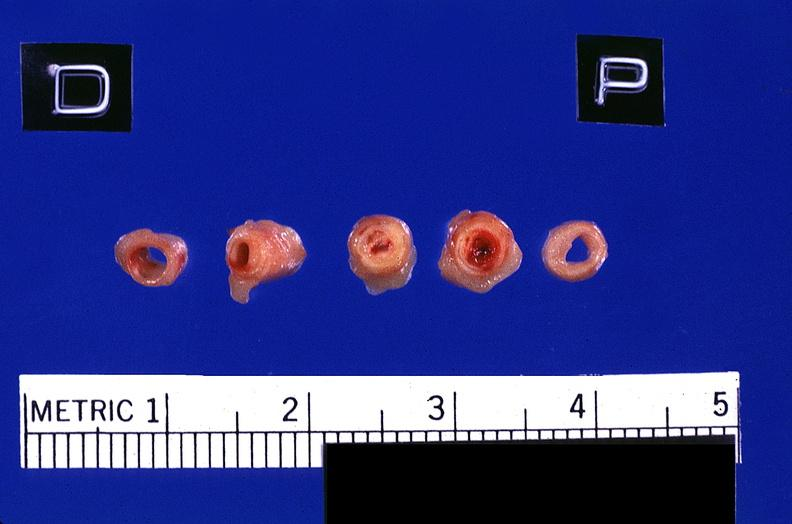s vasculature present?
Answer the question using a single word or phrase. Yes 